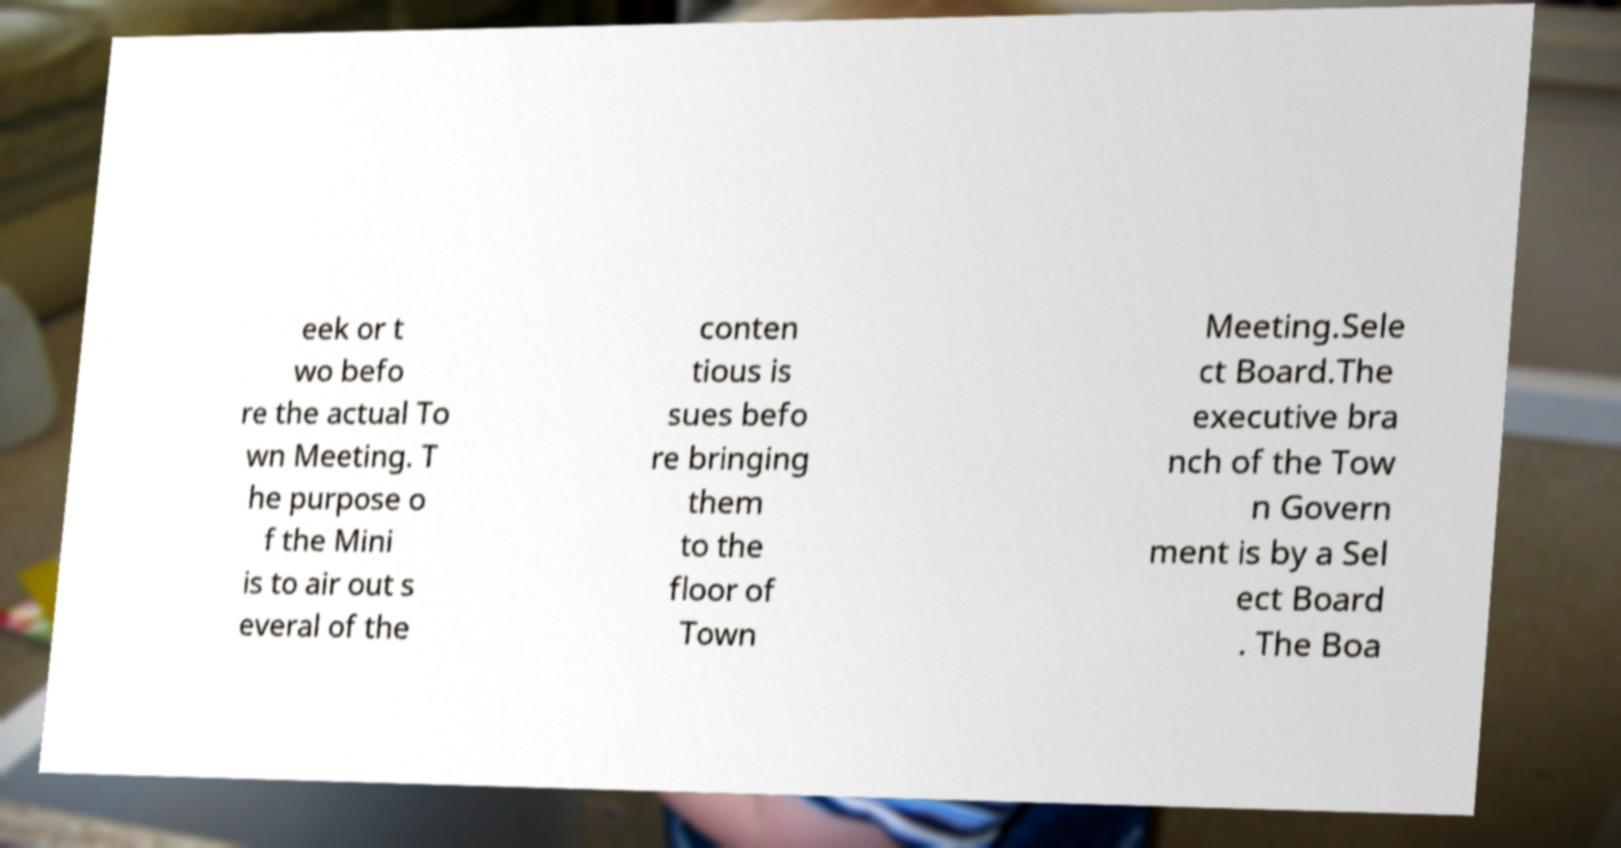Please identify and transcribe the text found in this image. eek or t wo befo re the actual To wn Meeting. T he purpose o f the Mini is to air out s everal of the conten tious is sues befo re bringing them to the floor of Town Meeting.Sele ct Board.The executive bra nch of the Tow n Govern ment is by a Sel ect Board . The Boa 